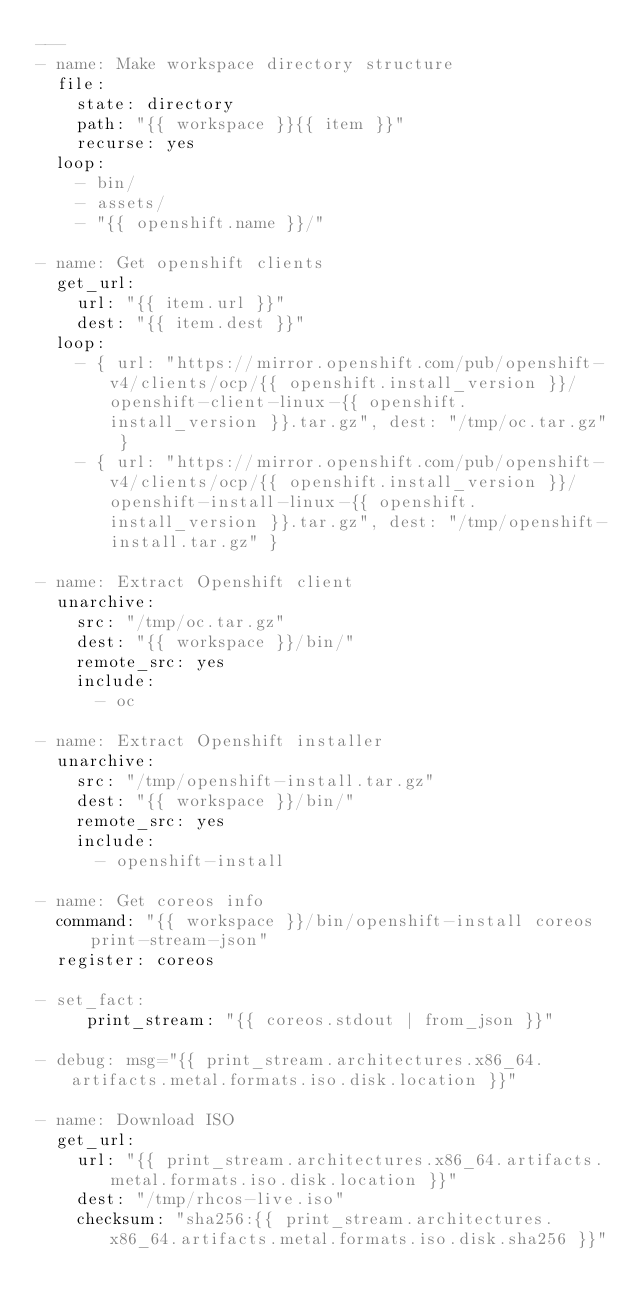Convert code to text. <code><loc_0><loc_0><loc_500><loc_500><_YAML_>---
- name: Make workspace directory structure
  file:
    state: directory
    path: "{{ workspace }}{{ item }}"
    recurse: yes
  loop:
    - bin/
    - assets/
    - "{{ openshift.name }}/"

- name: Get openshift clients
  get_url:
    url: "{{ item.url }}"
    dest: "{{ item.dest }}"
  loop:
    - { url: "https://mirror.openshift.com/pub/openshift-v4/clients/ocp/{{ openshift.install_version }}/openshift-client-linux-{{ openshift.install_version }}.tar.gz", dest: "/tmp/oc.tar.gz" }
    - { url: "https://mirror.openshift.com/pub/openshift-v4/clients/ocp/{{ openshift.install_version }}/openshift-install-linux-{{ openshift.install_version }}.tar.gz", dest: "/tmp/openshift-install.tar.gz" }

- name: Extract Openshift client
  unarchive:
    src: "/tmp/oc.tar.gz"
    dest: "{{ workspace }}/bin/"
    remote_src: yes
    include:
      - oc

- name: Extract Openshift installer
  unarchive:
    src: "/tmp/openshift-install.tar.gz"
    dest: "{{ workspace }}/bin/"
    remote_src: yes
    include:
      - openshift-install

- name: Get coreos info
  command: "{{ workspace }}/bin/openshift-install coreos print-stream-json"
  register: coreos

- set_fact:
     print_stream: "{{ coreos.stdout | from_json }}"

- debug: msg="{{ print_stream.architectures.x86_64.artifacts.metal.formats.iso.disk.location }}"

- name: Download ISO
  get_url:
    url: "{{ print_stream.architectures.x86_64.artifacts.metal.formats.iso.disk.location }}"
    dest: "/tmp/rhcos-live.iso"
    checksum: "sha256:{{ print_stream.architectures.x86_64.artifacts.metal.formats.iso.disk.sha256 }}"
</code> 